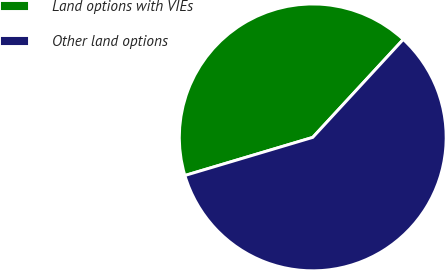Convert chart. <chart><loc_0><loc_0><loc_500><loc_500><pie_chart><fcel>Land options with VIEs<fcel>Other land options<nl><fcel>41.48%<fcel>58.52%<nl></chart> 